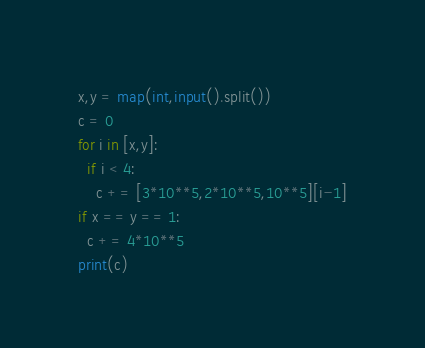Convert code to text. <code><loc_0><loc_0><loc_500><loc_500><_Python_>x,y = map(int,input().split())
c = 0
for i in [x,y]:
  if i < 4:
    c += [3*10**5,2*10**5,10**5][i-1]
if x == y == 1:
  c += 4*10**5
print(c)</code> 